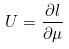<formula> <loc_0><loc_0><loc_500><loc_500>U = \frac { \partial l } { \partial \mu }</formula> 